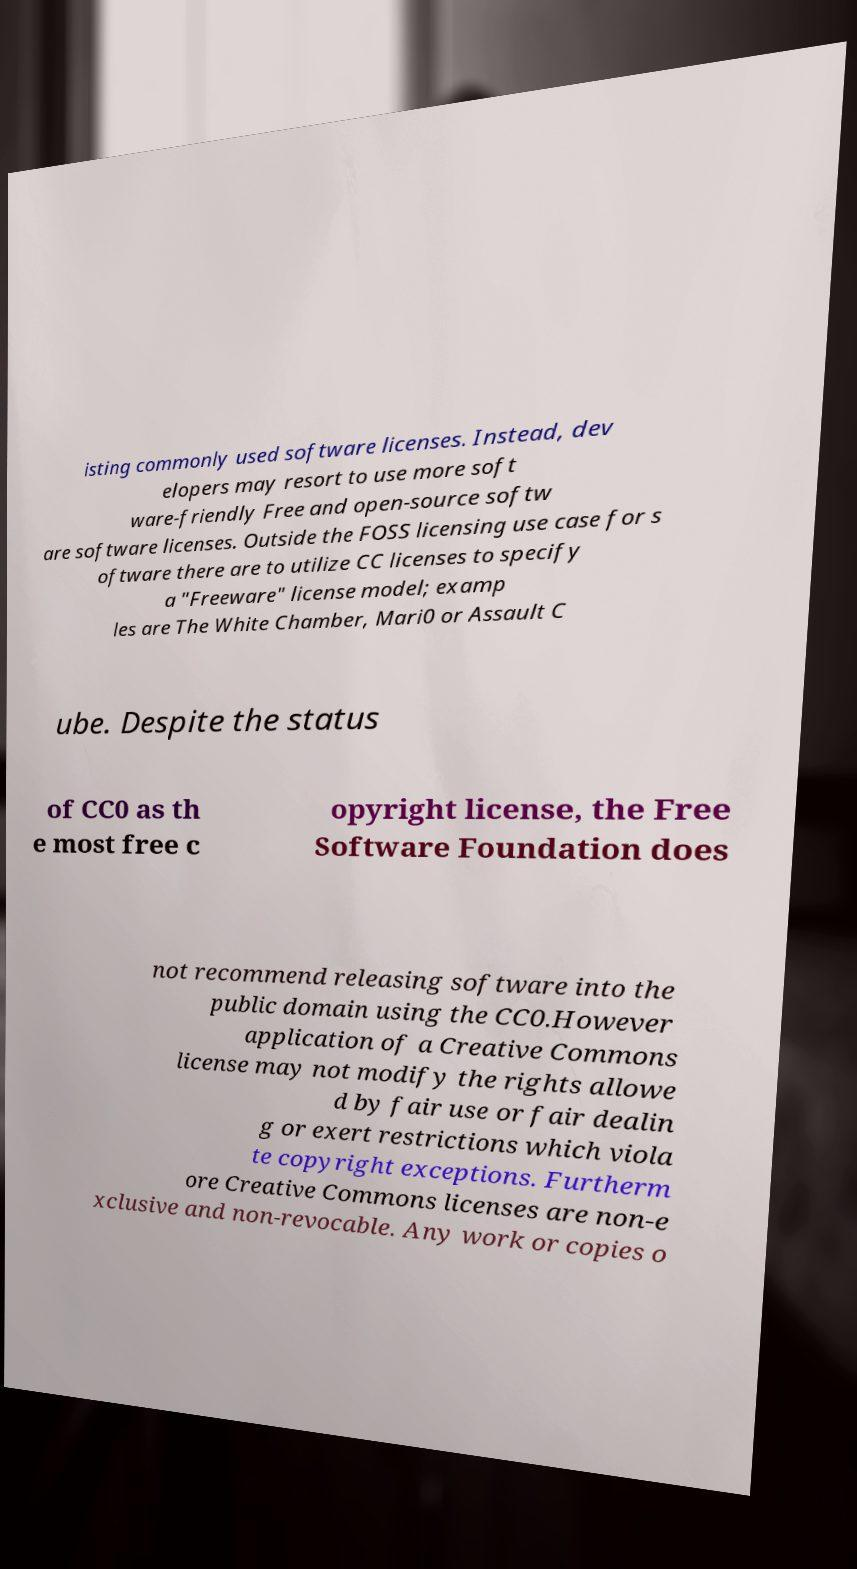Can you read and provide the text displayed in the image?This photo seems to have some interesting text. Can you extract and type it out for me? isting commonly used software licenses. Instead, dev elopers may resort to use more soft ware-friendly Free and open-source softw are software licenses. Outside the FOSS licensing use case for s oftware there are to utilize CC licenses to specify a "Freeware" license model; examp les are The White Chamber, Mari0 or Assault C ube. Despite the status of CC0 as th e most free c opyright license, the Free Software Foundation does not recommend releasing software into the public domain using the CC0.However application of a Creative Commons license may not modify the rights allowe d by fair use or fair dealin g or exert restrictions which viola te copyright exceptions. Furtherm ore Creative Commons licenses are non-e xclusive and non-revocable. Any work or copies o 